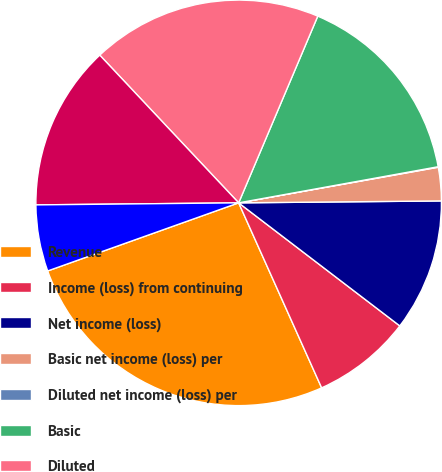<chart> <loc_0><loc_0><loc_500><loc_500><pie_chart><fcel>Revenue<fcel>Income (loss) from continuing<fcel>Net income (loss)<fcel>Basic net income (loss) per<fcel>Diluted net income (loss) per<fcel>Basic<fcel>Diluted<fcel>High<fcel>Low<nl><fcel>26.26%<fcel>7.91%<fcel>10.53%<fcel>2.66%<fcel>0.04%<fcel>15.77%<fcel>18.39%<fcel>13.15%<fcel>5.29%<nl></chart> 